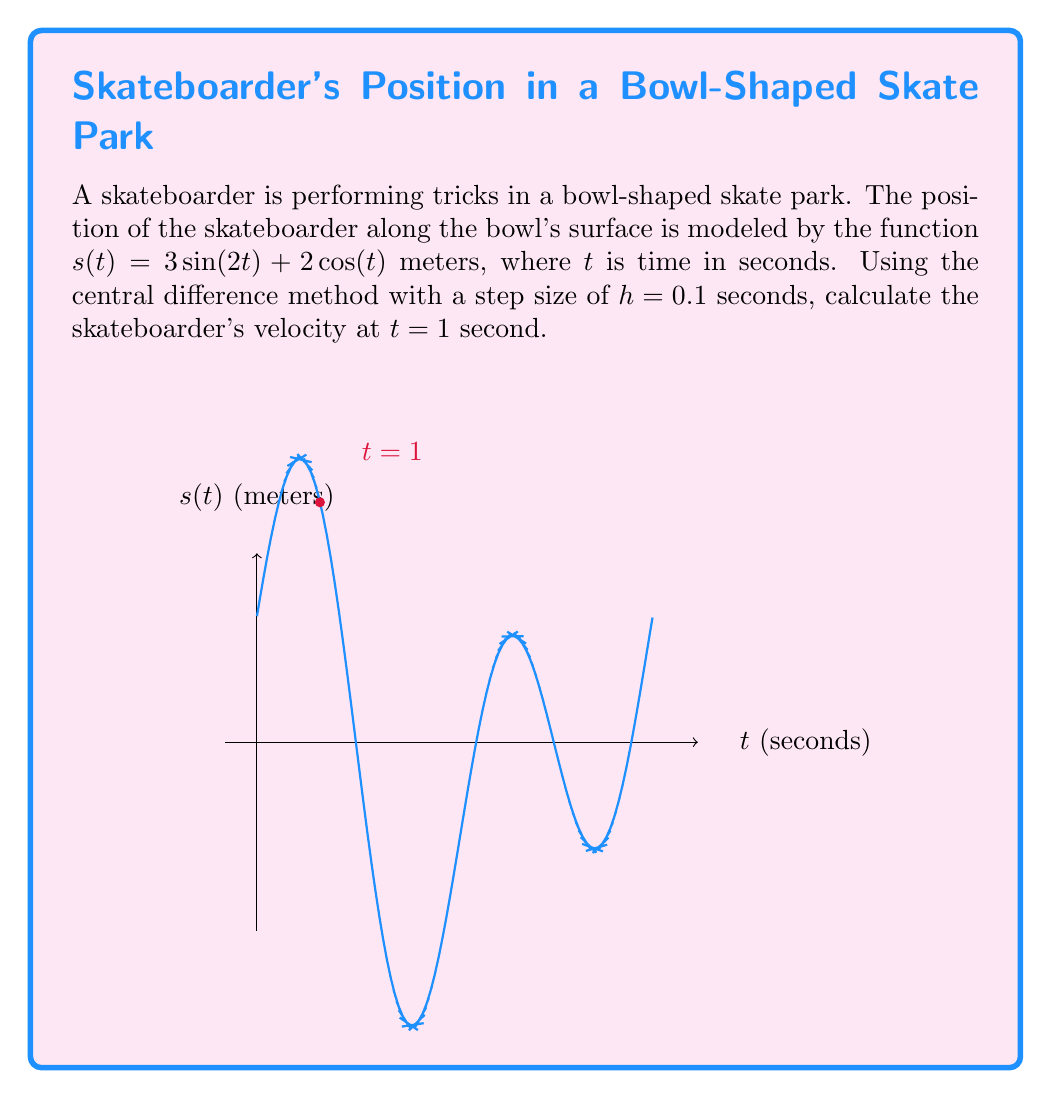Could you help me with this problem? To solve this problem, we'll use the central difference method for numerical differentiation. The formula for the central difference approximation of the first derivative (velocity) is:

$$v(t) \approx \frac{s(t+h) - s(t-h)}{2h}$$

Where $h$ is the step size, and $s(t)$ is the position function.

Given:
- $s(t) = 3\sin(2t) + 2\cos(t)$
- $h = 0.1$
- $t = 1$

Steps:
1) Calculate $s(t+h) = s(1+0.1) = s(1.1)$:
   $s(1.1) = 3\sin(2(1.1)) + 2\cos(1.1) = 3.8589$

2) Calculate $s(t-h) = s(1-0.1) = s(0.9)$:
   $s(0.9) = 3\sin(2(0.9)) + 2\cos(0.9) = 3.4355$

3) Apply the central difference formula:
   $$v(1) \approx \frac{s(1.1) - s(0.9)}{2(0.1)}$$
   $$v(1) \approx \frac{3.8589 - 3.4355}{0.2}$$
   $$v(1) \approx 2.117 \text{ m/s}$$

Therefore, the skateboarder's velocity at $t = 1$ second is approximately 2.117 m/s.
Answer: 2.117 m/s 